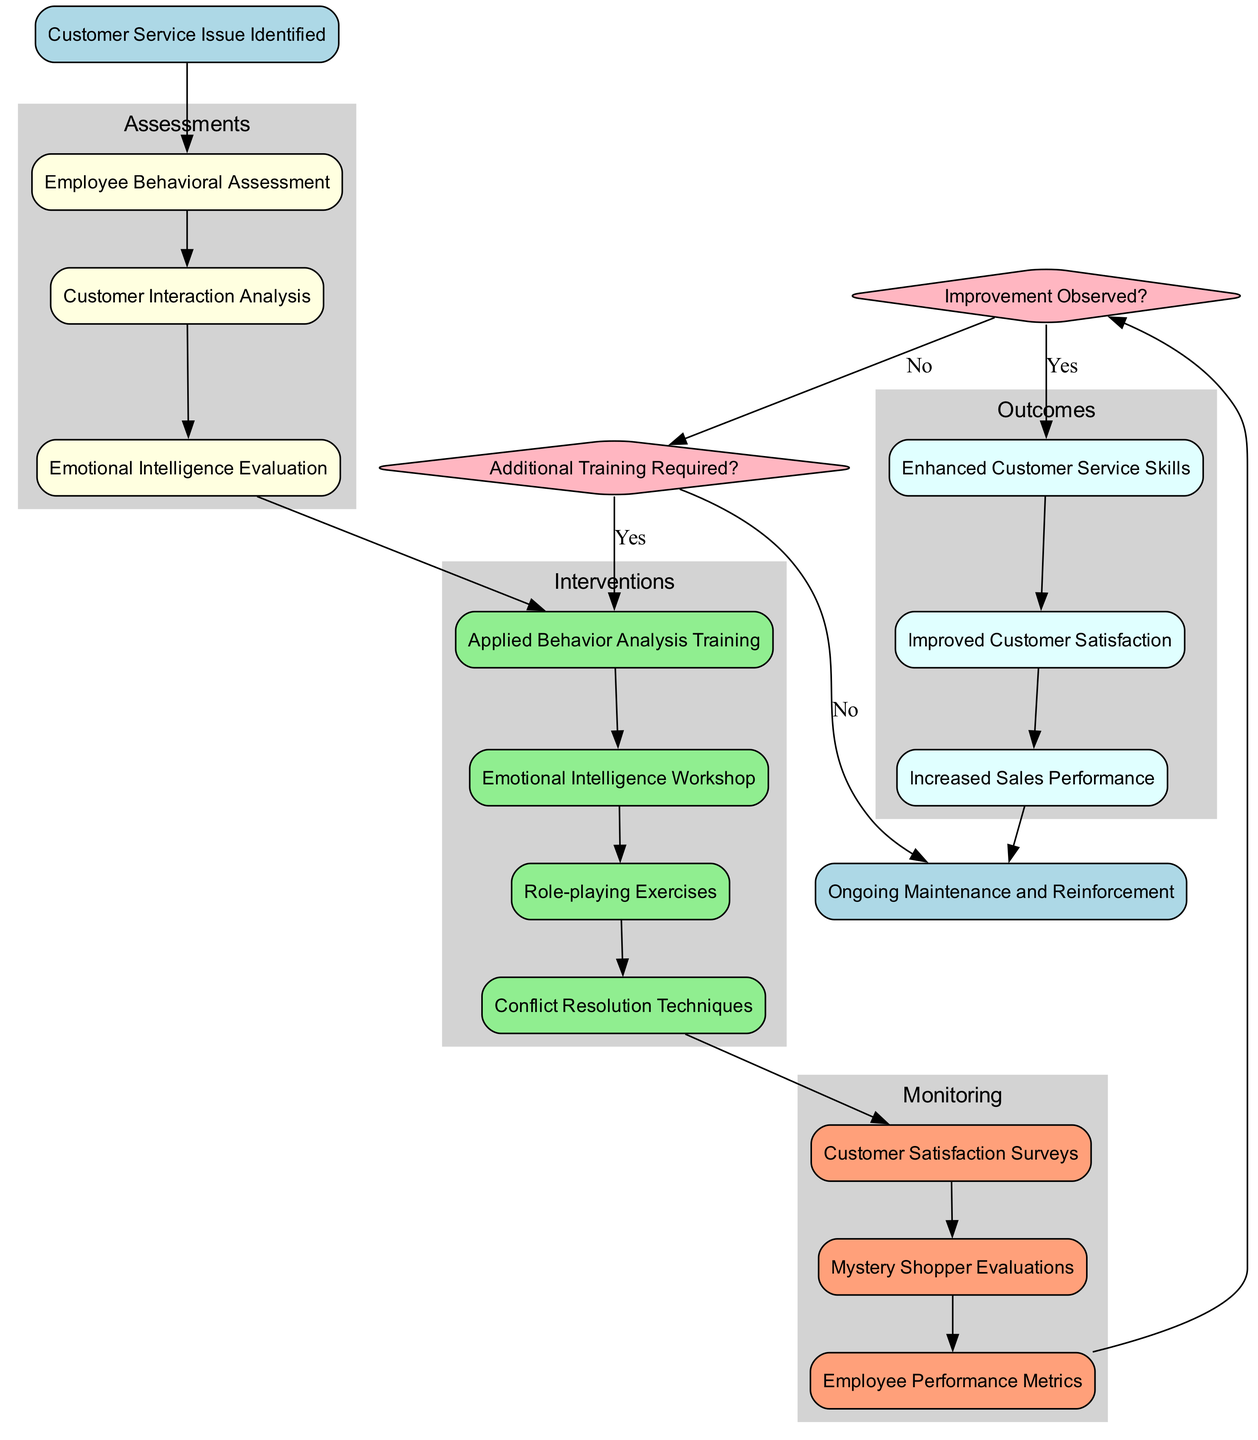What is the starting point of the clinical pathway? The starting point is labeled "Customer Service Issue Identified." It is directly indicated in the diagram as the first node.
Answer: Customer Service Issue Identified How many assessments are listed in the pathway? The diagram shows three assessments under the Assessments cluster. Counting them, we have: Employee Behavioral Assessment, Customer Interaction Analysis, and Emotional Intelligence Evaluation.
Answer: 3 Which intervention comes first in the pathway? The first intervention node after assessments is "Applied Behavior Analysis Training." It follows immediately after the last assessment node.
Answer: Applied Behavior Analysis Training What decision point follows the monitoring stage? After the monitoring stage, the next node is a decision point labeled "Improvement Observed?". This decision point comes directly after evaluating the monitoring metrics.
Answer: Improvement Observed? If the answer to "Improvement Observed?" is no, what is the next decision point? If "Improvement Observed?" is answered no, the flow leads to the next decision point "Additional Training Required?" This is the direct consequence of no improvement being observed.
Answer: Additional Training Required? What outcome is achieved if "Improvement Observed?" is answered yes? If "Improvement Observed?" is answered yes, the outcome achieved directly linked to this decision is "Enhanced Customer Service Skills." This node is the first of the outcomes listed.
Answer: Enhanced Customer Service Skills What are the last outcomes before final maintenance? The last two outcomes in the diagram are "Improved Customer Satisfaction" and "Increased Sales Performance." They are the last nodes before heading to the "Ongoing Maintenance and Reinforcement" end node.
Answer: Improved Customer Satisfaction, Increased Sales Performance How many monitoring techniques are included in the pathway? The diagram outlines three monitoring techniques, which are: Customer Satisfaction Surveys, Mystery Shopper Evaluations, and Employee Performance Metrics. These are grouped in the Monitoring section.
Answer: 3 What color represents the intervention nodes in the diagram? The intervention nodes are represented with a light green fill color. This can be visually identified in the color coding of the diagram.
Answer: Light green 